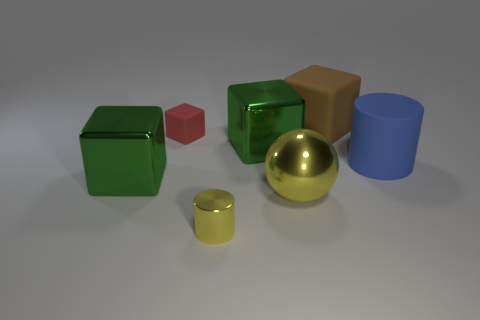Are any objects visible?
Make the answer very short. Yes. There is a tiny thing on the left side of the small yellow cylinder; does it have the same shape as the green object on the left side of the red block?
Offer a very short reply. Yes. How many small things are either shiny objects or blue rubber objects?
Your answer should be compact. 1. The tiny object that is made of the same material as the yellow ball is what shape?
Give a very brief answer. Cylinder. Is the shape of the red thing the same as the blue matte object?
Give a very brief answer. No. The ball has what color?
Offer a very short reply. Yellow. What number of things are either big blue things or red metal cubes?
Your response must be concise. 1. Are there any other things that are the same material as the red block?
Offer a very short reply. Yes. Is the number of yellow spheres to the left of the small yellow shiny cylinder less than the number of big red shiny cubes?
Your answer should be compact. No. Is the number of small matte things that are in front of the yellow sphere greater than the number of metallic spheres that are to the left of the big cylinder?
Offer a terse response. No. 